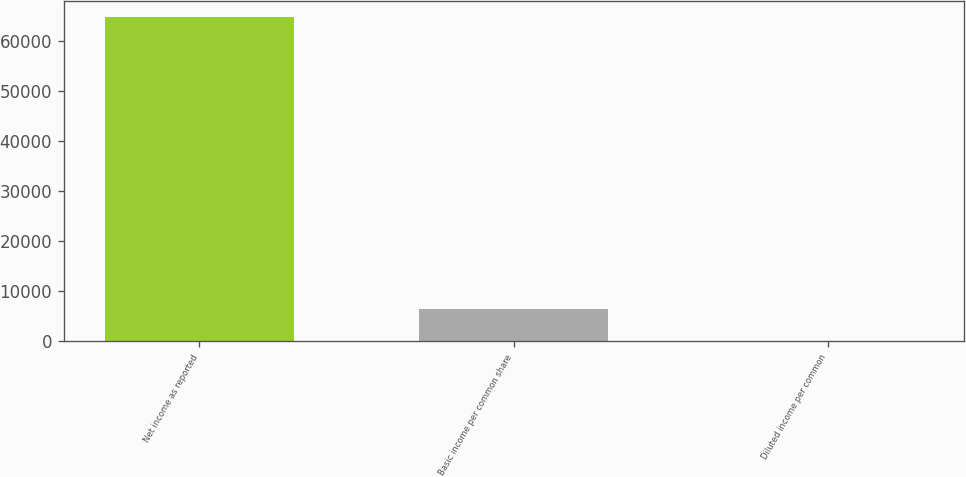Convert chart. <chart><loc_0><loc_0><loc_500><loc_500><bar_chart><fcel>Net income as reported<fcel>Basic income per common share<fcel>Diluted income per common<nl><fcel>64731<fcel>6473.68<fcel>0.64<nl></chart> 